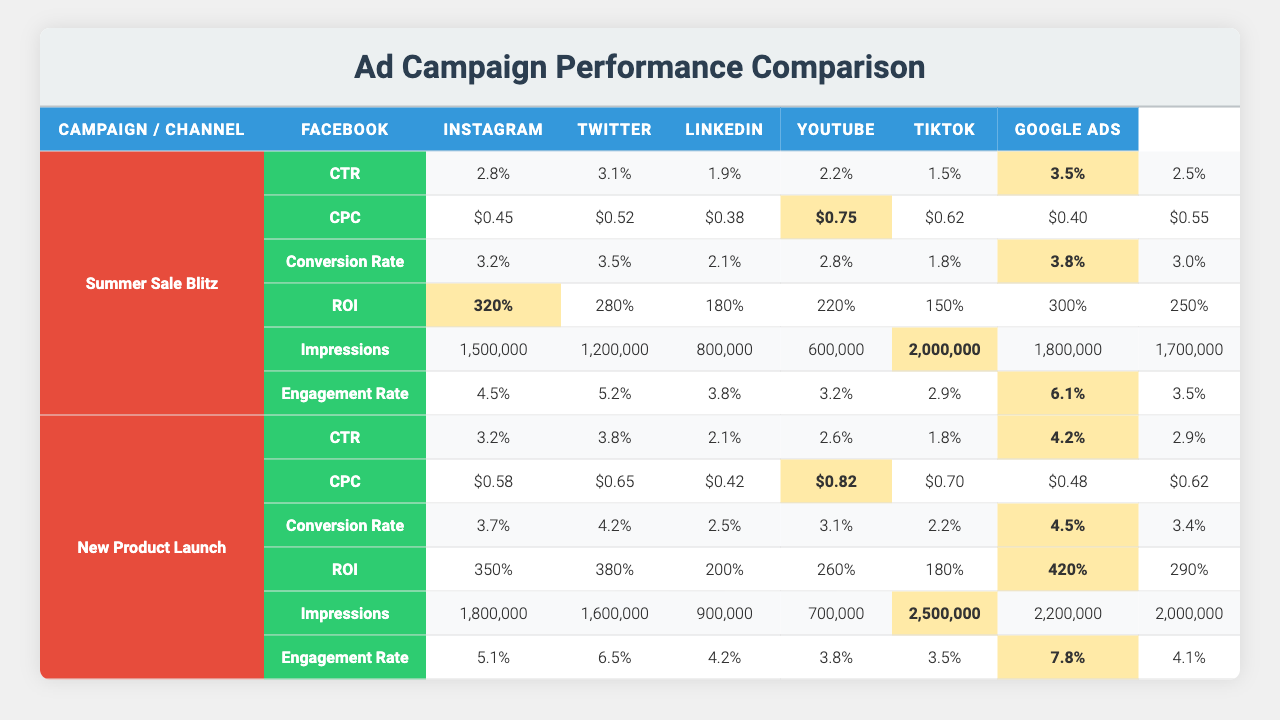What is the highest CTR for the "Summer Sale Blitz" campaign? Looking at the "Summer Sale Blitz" campaign row, the CTRs for each channel are as follows: Facebook (2.8%), Instagram (3.1%), Twitter (1.9%), LinkedIn (2.2%), YouTube (1.5%), TikTok (3.5%), and Google Ads (2.5%). The highest value is from TikTok at 3.5%.
Answer: 3.5% Which channel had the lowest CPC in the "New Product Launch" campaign? In the "New Product Launch" campaign, the CPC values for the channels are: Facebook ($0.58), Instagram ($0.65), Twitter ($0.42), LinkedIn ($0.82), YouTube ($0.70), TikTok ($0.48), and Google Ads ($0.62). The lowest is Twitter at $0.42.
Answer: $0.42 What is the average Conversion Rate across all channels in the "Summer Sale Blitz" campaign? The Conversion Rates for "Summer Sale Blitz" are: Facebook (3.2%), Instagram (3.5%), Twitter (2.1%), LinkedIn (2.8%), YouTube (1.8%), TikTok (3.8%), Google Ads (3.0%). Summing these gives 3.2 + 3.5 + 2.1 + 2.8 + 1.8 + 3.8 + 3.0 = 20.2%. Dividing by the number of channels (7) gives an average of 20.2/7 = 2.89%.
Answer: 2.89% Did TikTok outperform Instagram in terms of Engagement Rate for both campaigns? For the "Summer Sale Blitz," TikTok has an Engagement Rate of 6.1%, while Instagram has 5.2%. In the "New Product Launch," TikTok has 7.8%, and Instagram has 6.5%. In both campaigns, TikTok's Engagement Rate is higher than Instagram's.
Answer: Yes What is the total ROI for the "New Product Launch" campaign across all channels? The ROIs for the "New Product Launch" campaign are: Facebook (350%), Instagram (380%), Twitter (200%), LinkedIn (260%), YouTube (180%), TikTok (420%), and Google Ads (290%). Summing these gives 350 + 380 + 200 + 260 + 180 + 420 + 290 = 2080%.
Answer: 2080% Which channel had the highest average Impressions across both campaigns? For "Summer Sale Blitz," the Impressions are: Facebook (1,500,000), Instagram (1,200,000), Twitter (800,000), LinkedIn (600,000), YouTube (2,000,000), TikTok (1,800,000), Google Ads (1,700,000). For "New Product Launch," they are: Facebook (1,800,000), Instagram (1,600,000), Twitter (900,000), LinkedIn (700,000), YouTube (2,500,000), TikTok (2,200,000), Google Ads (2,000,000). Summing and averaging gives: Facebook (1,650,000), Instagram (1,400,000), Twitter (850,000), LinkedIn (650,000), YouTube (2,250,000), TikTok (2,000,000), Google Ads (1,850,000). The highest average is for YouTube at 2,250,000.
Answer: 2,250,000 What is the difference in Engagement Rate between the highest and lowest channels for the "Summer Sale Blitz"? From "Summer Sale Blitz," the highest Engagement Rate is TikTok (6.1%), and the lowest is YouTube (2.9%). The difference is 6.1% - 2.9% = 3.2%.
Answer: 3.2% 